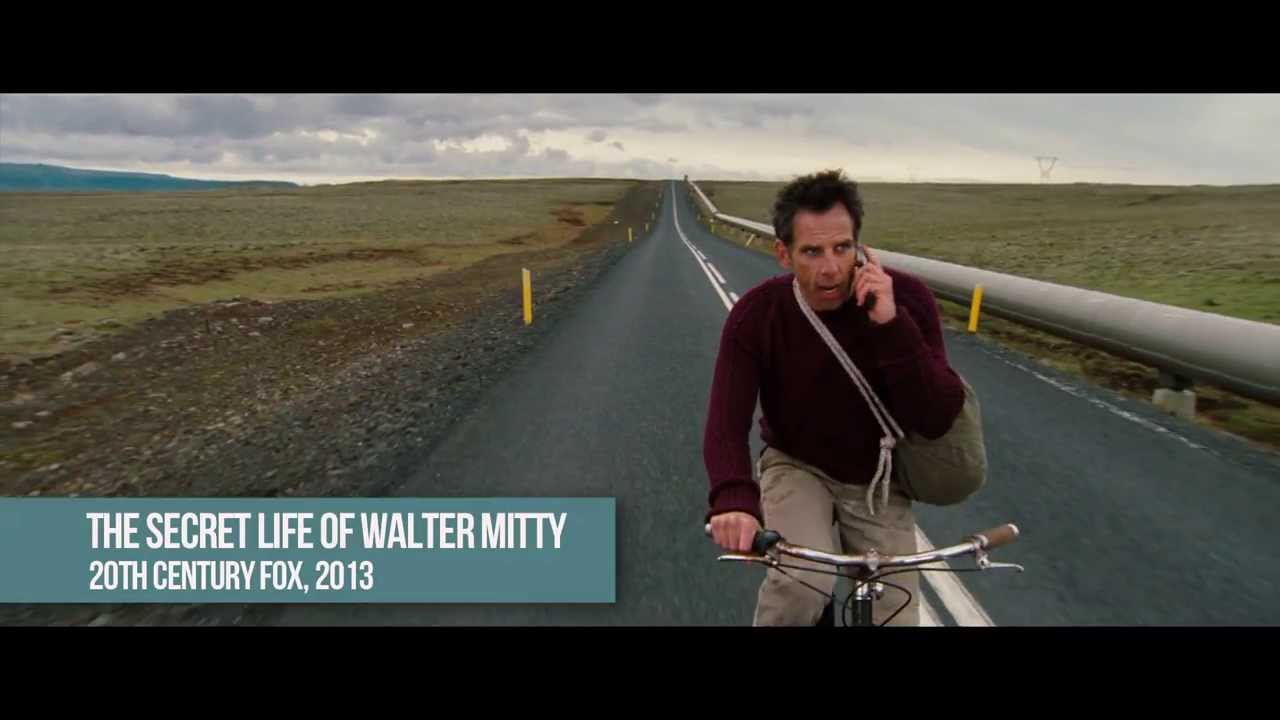Explain the visual content of the image in great detail. The image portrays a man cycling on a narrow, paved road that stretches into a vast, open landscape. The terrain on either side of the road is flat and barren, with sparse vegetation, under an overcast sky that imbues the scene with a somber, poignant mood. The man, dressed in a maroon sweater, appears focused and slightly anxious, as he talks on a cell phone while pedaling. The overall color palette of blues and grays further emphasizes the mood of isolation and introspection. 